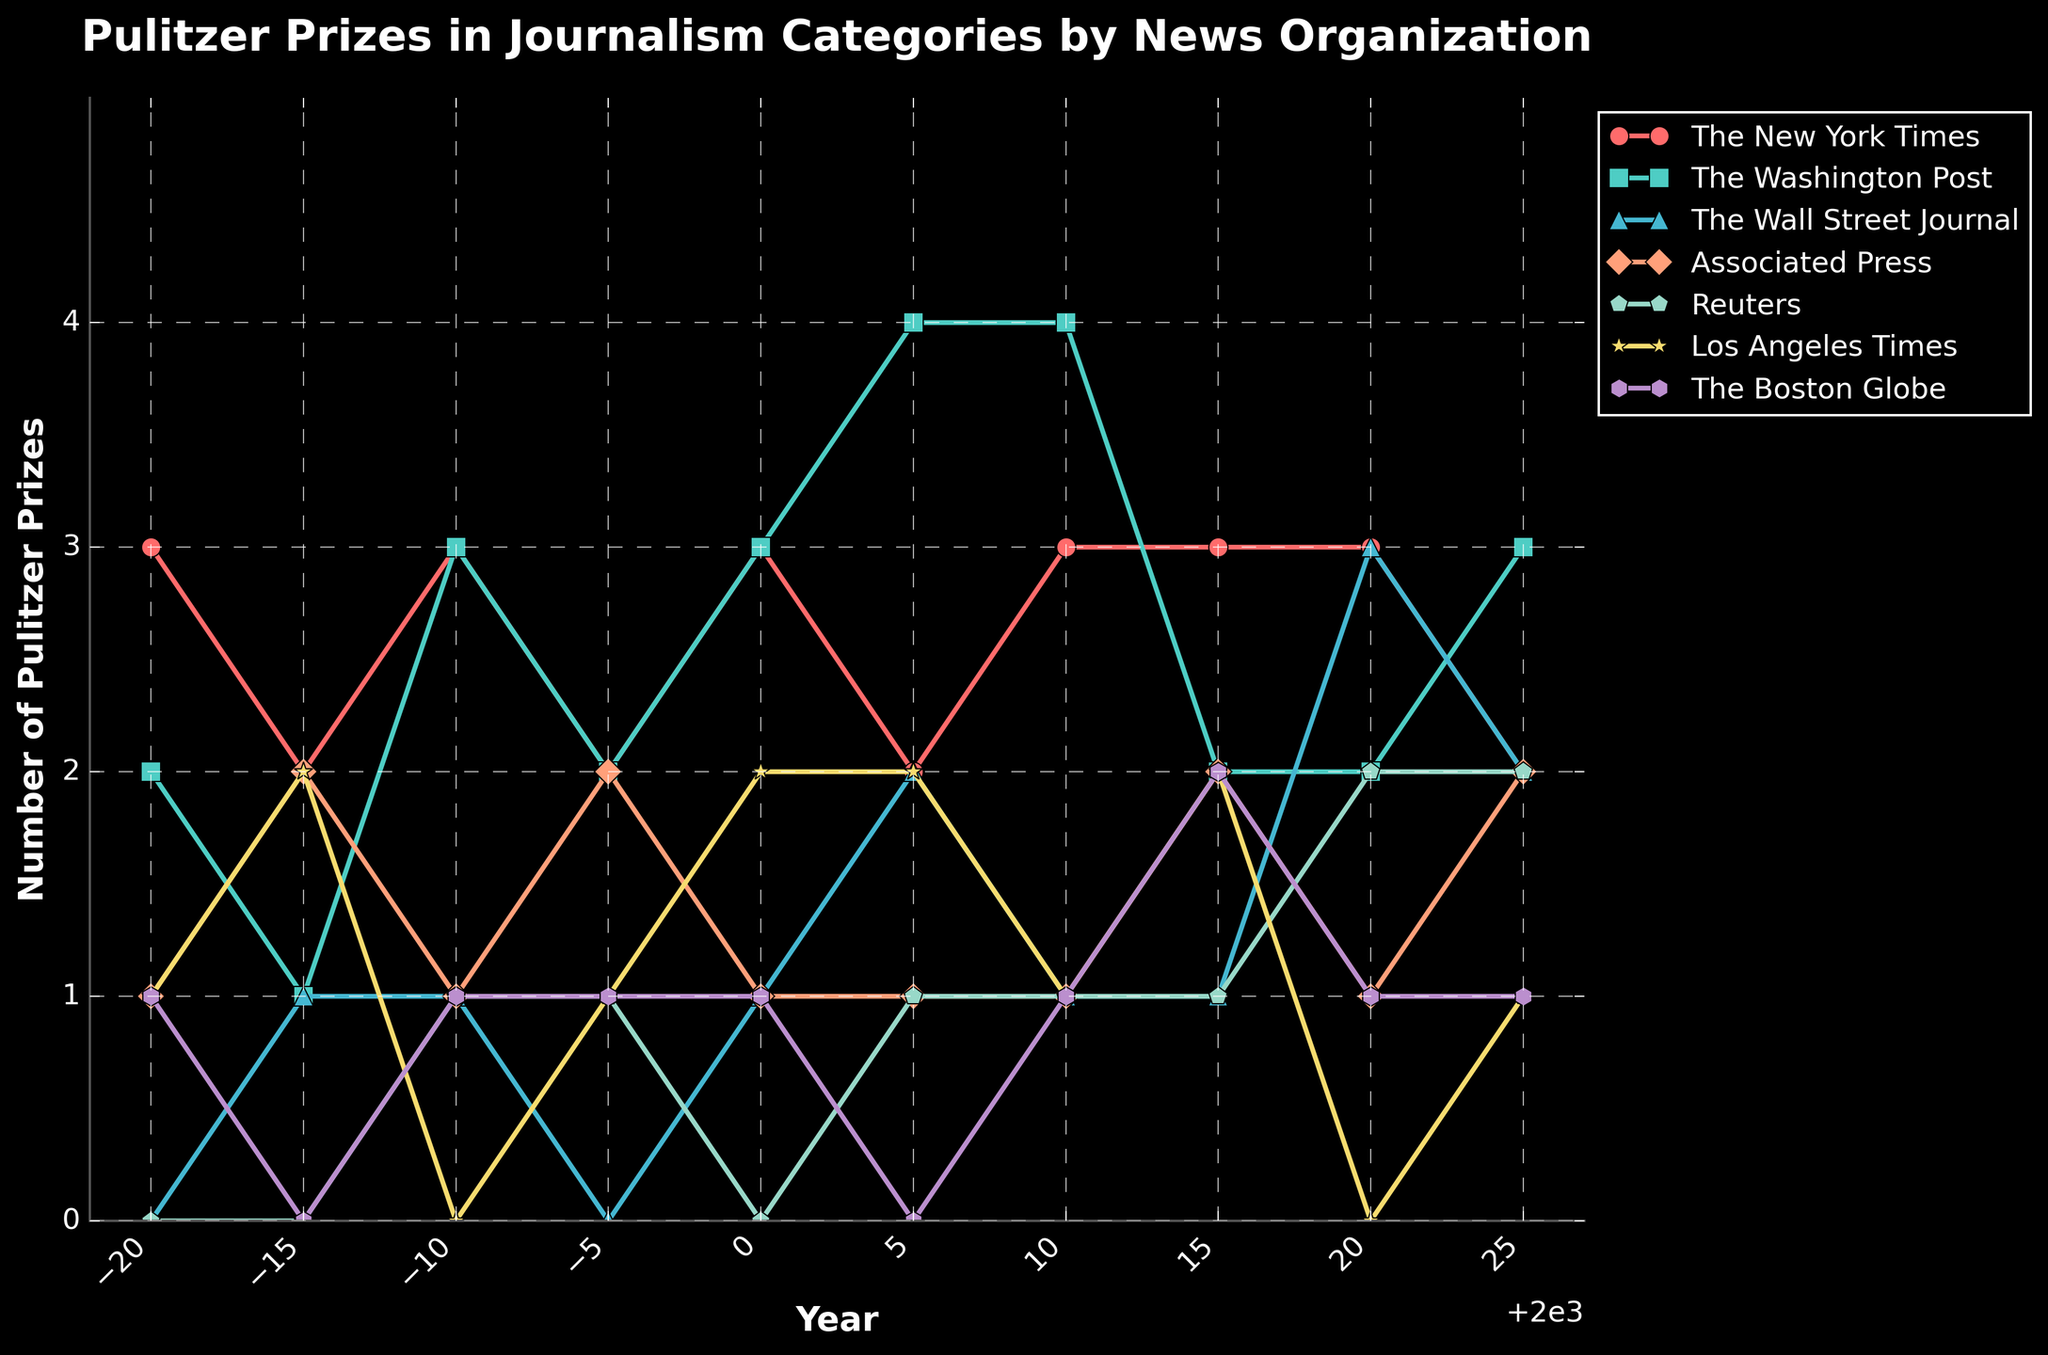Which news organization had the highest number of Pulitzer Prizes in 2005? Looking at the 2005 data points, The Washington Post had the highest number of Pulitzer Prizes with 4.
Answer: The Washington Post Which years did The New York Times and The Washington Post tie in the number of Pulitzer Prizes? Comparing the data for The New York Times and The Washington Post over the years, they tied twice: in 1980 with 3 prizes each, and in 2000 with 3 prizes each.
Answer: 1980, 2000 Between 1980 and 2020, how many times did The Wall Street Journal win exactly 2 Pulitzer Prizes? Scanning through The Wall Street Journal’s data points, it won exactly 2 Pulitzer Prizes in 2005 and 2025, totaling 2 instances.
Answer: 2 In which year did Reuters see the highest number of Pulitzer Prizes? Reviewing the data for Reuters, the highest number of Pulitzer Prizes was 2, occurring in 2020 and 2025.
Answer: 2020, 2025 What is the sum of Pulitzer Prizes won by the Los Angeles Times from 2000 to 2025? Summing the number of Pulitzer Prizes that the Los Angeles Times won from 2000 to 2025: 2 (2000) + 2 (2005) + 1 (2010) + 2 (2015) + 0 (2020) + 1 (2025) = 8
Answer: 8 Which news organization has the most fluctuating trend of Pulitzer Prize wins over the years? Observing the trends, The Washington Post shows the most fluctuation, with wins ranging from 1 to 4 prizes across different years.
Answer: The Washington Post What is the average number of Pulitzer Prizes won by The Boston Globe from 1980 to 2025? Calculating the average: (1 + 0 + 1 + 1 + 1 + 0 + 1 + 2 + 1 + 1)/10 = 9/10 = 0.9
Answer: 0.9 How many total Pulitzer Prizes did Associated Press win between 1980 and 2025? Summing the total Pulitzer Prizes for Associated Press: 1 (1980) + 2 (1985) + 1 (1990) + 2 (1995) + 1 (2000) + 1 (2005) + 1 (2010) + 2 (2015) + 1 (2020) + 2 (2025) = 14
Answer: 14 In which year did The New York Times win the fewest Pulitzer Prizes? Referring to the data, in 2025 The New York Times won the fewest Pulitzer Prizes with 2.
Answer: 2025 Who won more Pulitzer Prizes in 2020: Reuters or The New York Times? Comparing the 2020 data, The New York Times won 3 Pulitzer Prizes and Reuters won 2 Pulitzer Prizes.
Answer: The New York Times 